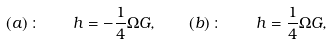Convert formula to latex. <formula><loc_0><loc_0><loc_500><loc_500>( a ) \, \colon \quad h = - \frac { 1 } { 4 } \Omega G , \quad ( b ) \, \colon \quad h = \frac { 1 } { 4 } \Omega G ,</formula> 